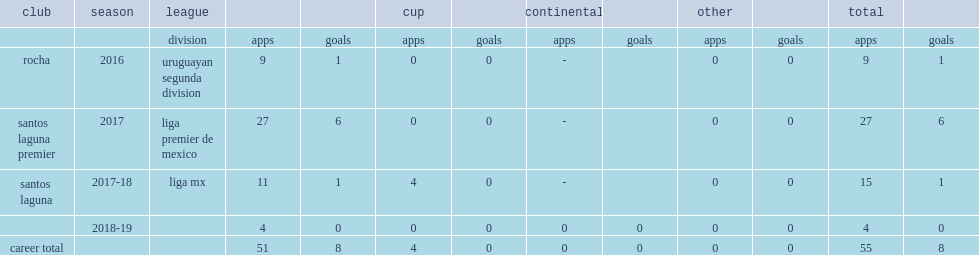Which club did cetre play for in 2016? Rocha. Help me parse the entirety of this table. {'header': ['club', 'season', 'league', '', '', 'cup', '', 'continental', '', 'other', '', 'total', ''], 'rows': [['', '', 'division', 'apps', 'goals', 'apps', 'goals', 'apps', 'goals', 'apps', 'goals', 'apps', 'goals'], ['rocha', '2016', 'uruguayan segunda division', '9', '1', '0', '0', '-', '', '0', '0', '9', '1'], ['santos laguna premier', '2017', 'liga premier de mexico', '27', '6', '0', '0', '-', '', '0', '0', '27', '6'], ['santos laguna', '2017-18', 'liga mx', '11', '1', '4', '0', '-', '', '0', '0', '15', '1'], ['', '2018-19', '', '4', '0', '0', '0', '0', '0', '0', '0', '4', '0'], ['career total', '', '', '51', '8', '4', '0', '0', '0', '0', '0', '55', '8']]} 